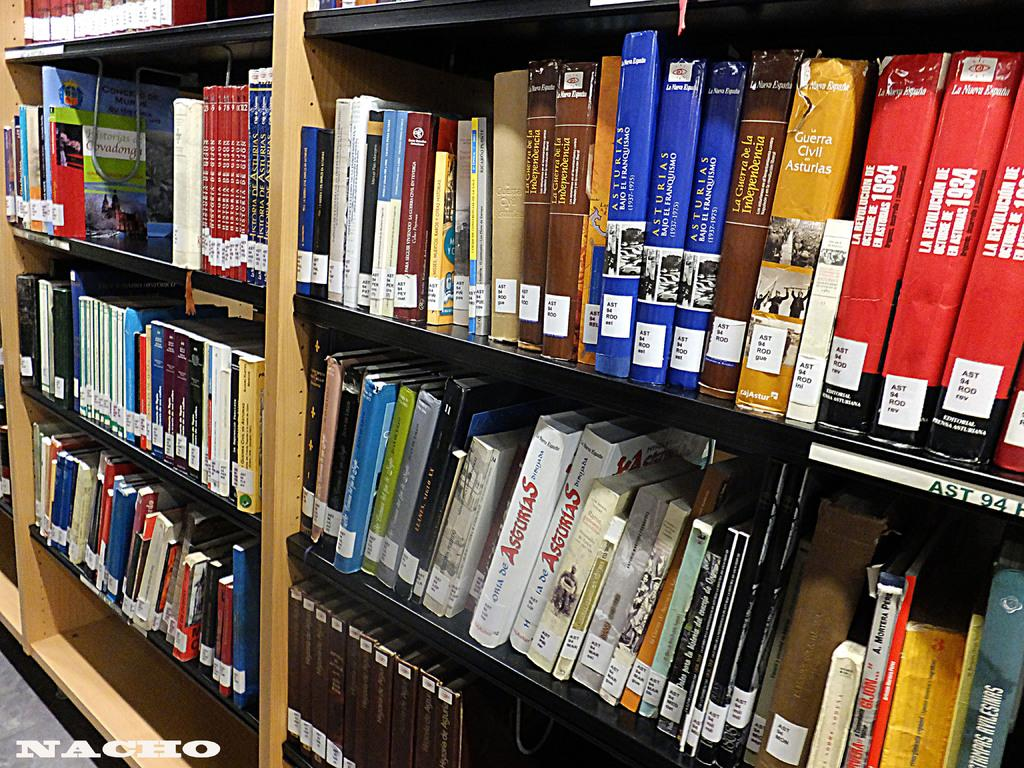<image>
Write a terse but informative summary of the picture. A library shelf full of books in the AST section. 